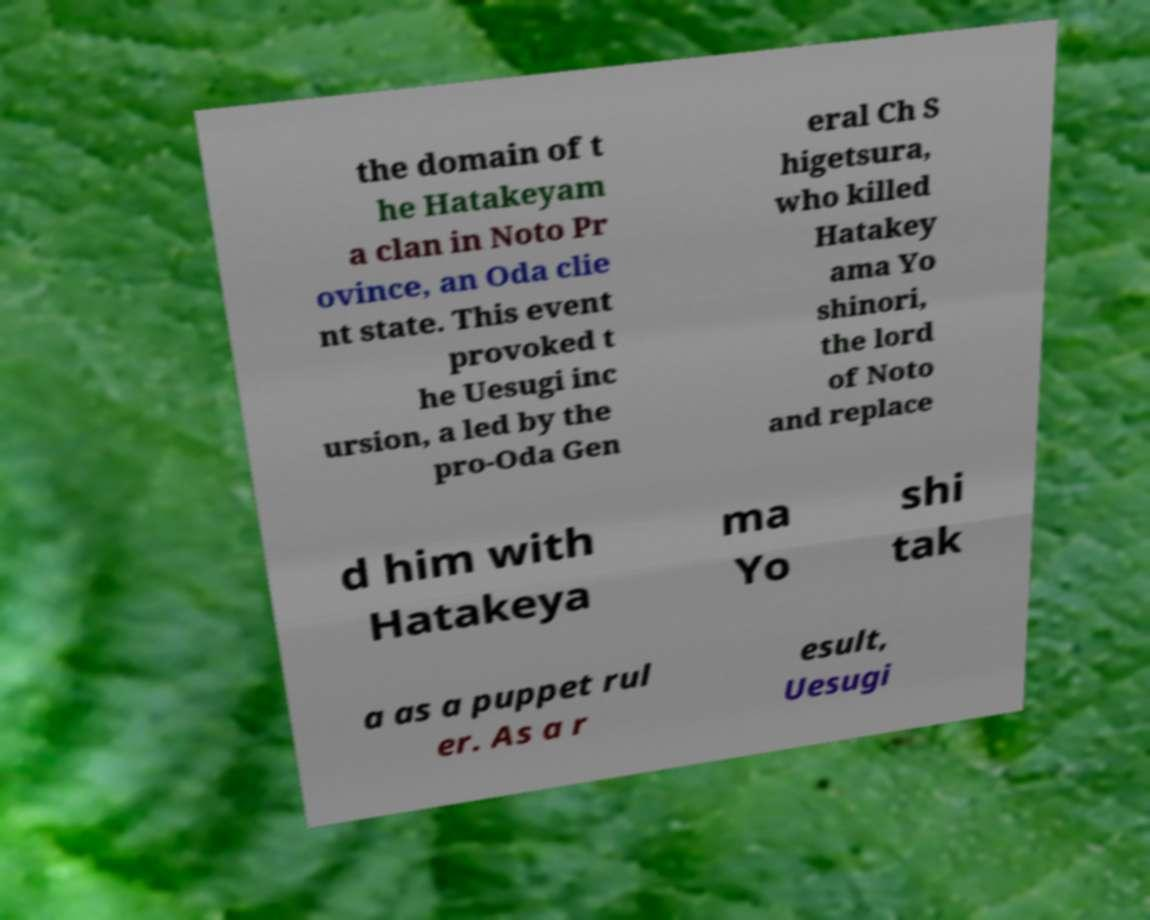Can you accurately transcribe the text from the provided image for me? the domain of t he Hatakeyam a clan in Noto Pr ovince, an Oda clie nt state. This event provoked t he Uesugi inc ursion, a led by the pro-Oda Gen eral Ch S higetsura, who killed Hatakey ama Yo shinori, the lord of Noto and replace d him with Hatakeya ma Yo shi tak a as a puppet rul er. As a r esult, Uesugi 